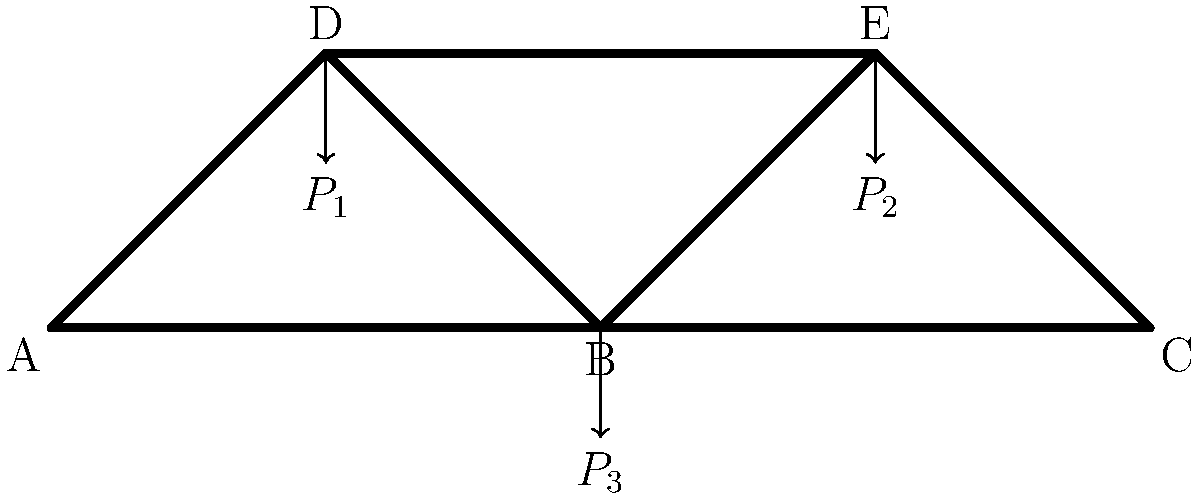A truss bridge structure is subjected to three point loads: $P_1 = 50$ kN at node D, $P_2 = 75$ kN at node E, and $P_3 = 100$ kN at node B. Assuming the truss is statically determinate and all joints are pinned, determine the axial force in member DE. State whether the member is in tension or compression. To solve this problem, we'll follow these steps:

1) First, we need to calculate the reaction forces at the supports (nodes A and C).

2) We can use the method of joints to analyze the forces in the truss members.

3) We'll start at node D and work our way to member DE.

Step 1: Calculate reaction forces
Using moment equilibrium about point A:
$$\sum M_A = 0: 200R_C - 50P_1 - 150P_2 - 100P_3 = 0$$
$$200R_C - 50(50) - 150(75) - 100(100) = 0$$
$$200R_C = 2500 + 11250 + 10000 = 23750$$
$$R_C = 118.75 \text{ kN (upward)}$$

Using vertical force equilibrium:
$$\sum F_y = 0: R_A + R_C - P_1 - P_2 - P_3 = 0$$
$$R_A + 118.75 - 50 - 75 - 100 = 0$$
$$R_A = 106.25 \text{ kN (upward)}$$

Step 2: Analyze node D
At node D, we have two unknown forces (in members AD and DE) and one known force ($P_1$).

Using force equilibrium in the y-direction:
$$\sum F_y = 0: F_{AD}\sin(45°) + F_{DE}\cos(0°) - P_1 = 0$$
$$0.707F_{AD} + F_{DE} - 50 = 0 \quad (1)$$

Using force equilibrium in the x-direction:
$$\sum F_x = 0: F_{AD}\cos(45°) - F_{DE}\sin(0°) = 0$$
$$0.707F_{AD} = 0 \quad (2)$$

From equation (2), we can see that $F_{AD} = 0$.

Substituting this into equation (1):
$$F_{DE} - 50 = 0$$
$$F_{DE} = 50 \text{ kN}$$

Step 3: Determine if DE is in tension or compression
Since the force in member DE is pushing away from node D, the member is in tension.
Answer: Member DE experiences a tensile force of 50 kN. 